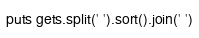Convert code to text. <code><loc_0><loc_0><loc_500><loc_500><_Ruby_>puts gets.split(' ').sort().join(' ')</code> 